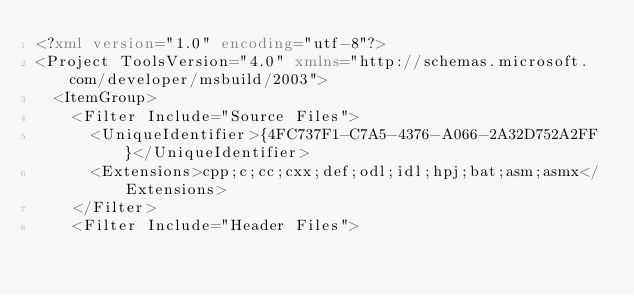Convert code to text. <code><loc_0><loc_0><loc_500><loc_500><_XML_><?xml version="1.0" encoding="utf-8"?>
<Project ToolsVersion="4.0" xmlns="http://schemas.microsoft.com/developer/msbuild/2003">
  <ItemGroup>
    <Filter Include="Source Files">
      <UniqueIdentifier>{4FC737F1-C7A5-4376-A066-2A32D752A2FF}</UniqueIdentifier>
      <Extensions>cpp;c;cc;cxx;def;odl;idl;hpj;bat;asm;asmx</Extensions>
    </Filter>
    <Filter Include="Header Files"></code> 